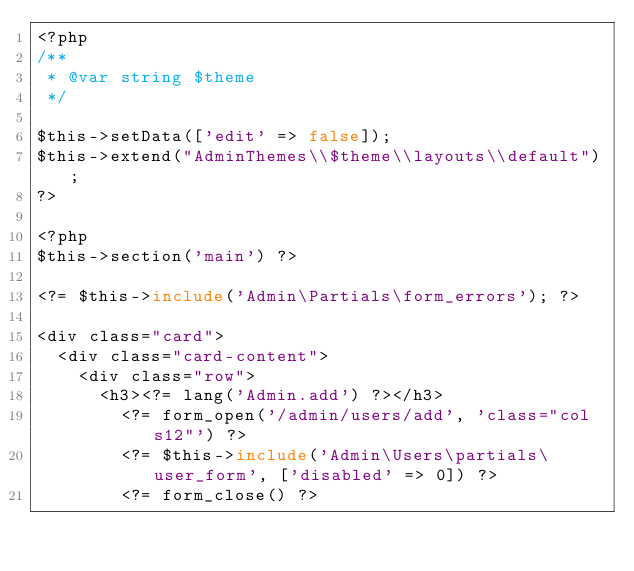<code> <loc_0><loc_0><loc_500><loc_500><_PHP_><?php
/**
 * @var string $theme
 */

$this->setData(['edit' => false]);
$this->extend("AdminThemes\\$theme\\layouts\\default");
?>

<?php
$this->section('main') ?>

<?= $this->include('Admin\Partials\form_errors'); ?>

<div class="card">
  <div class="card-content">
    <div class="row">
      <h3><?= lang('Admin.add') ?></h3>
        <?= form_open('/admin/users/add', 'class="col s12"') ?>
        <?= $this->include('Admin\Users\partials\user_form', ['disabled' => 0]) ?>
        <?= form_close() ?></code> 